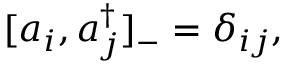Convert formula to latex. <formula><loc_0><loc_0><loc_500><loc_500>[ a _ { i } , a _ { j } ^ { \dagger } ] _ { - } = \delta _ { i j } ,</formula> 